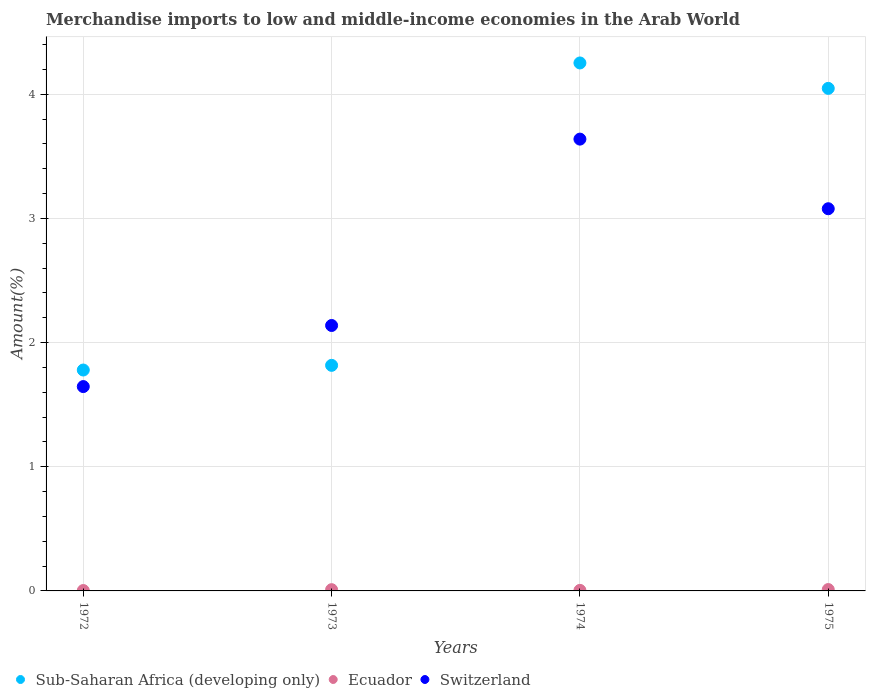What is the percentage of amount earned from merchandise imports in Sub-Saharan Africa (developing only) in 1972?
Your answer should be compact. 1.78. Across all years, what is the maximum percentage of amount earned from merchandise imports in Switzerland?
Provide a short and direct response. 3.64. Across all years, what is the minimum percentage of amount earned from merchandise imports in Sub-Saharan Africa (developing only)?
Make the answer very short. 1.78. In which year was the percentage of amount earned from merchandise imports in Sub-Saharan Africa (developing only) maximum?
Make the answer very short. 1974. In which year was the percentage of amount earned from merchandise imports in Switzerland minimum?
Your response must be concise. 1972. What is the total percentage of amount earned from merchandise imports in Sub-Saharan Africa (developing only) in the graph?
Your answer should be very brief. 11.9. What is the difference between the percentage of amount earned from merchandise imports in Switzerland in 1974 and that in 1975?
Your answer should be compact. 0.56. What is the difference between the percentage of amount earned from merchandise imports in Switzerland in 1975 and the percentage of amount earned from merchandise imports in Ecuador in 1972?
Provide a short and direct response. 3.08. What is the average percentage of amount earned from merchandise imports in Sub-Saharan Africa (developing only) per year?
Make the answer very short. 2.97. In the year 1974, what is the difference between the percentage of amount earned from merchandise imports in Switzerland and percentage of amount earned from merchandise imports in Ecuador?
Offer a terse response. 3.63. In how many years, is the percentage of amount earned from merchandise imports in Sub-Saharan Africa (developing only) greater than 3.4 %?
Your response must be concise. 2. What is the ratio of the percentage of amount earned from merchandise imports in Ecuador in 1973 to that in 1975?
Give a very brief answer. 0.91. What is the difference between the highest and the second highest percentage of amount earned from merchandise imports in Switzerland?
Ensure brevity in your answer.  0.56. What is the difference between the highest and the lowest percentage of amount earned from merchandise imports in Switzerland?
Offer a very short reply. 1.99. Does the percentage of amount earned from merchandise imports in Sub-Saharan Africa (developing only) monotonically increase over the years?
Ensure brevity in your answer.  No. Is the percentage of amount earned from merchandise imports in Switzerland strictly less than the percentage of amount earned from merchandise imports in Sub-Saharan Africa (developing only) over the years?
Make the answer very short. No. How many dotlines are there?
Make the answer very short. 3. What is the difference between two consecutive major ticks on the Y-axis?
Offer a terse response. 1. What is the title of the graph?
Give a very brief answer. Merchandise imports to low and middle-income economies in the Arab World. Does "Comoros" appear as one of the legend labels in the graph?
Your answer should be compact. No. What is the label or title of the X-axis?
Your answer should be very brief. Years. What is the label or title of the Y-axis?
Offer a terse response. Amount(%). What is the Amount(%) of Sub-Saharan Africa (developing only) in 1972?
Keep it short and to the point. 1.78. What is the Amount(%) in Ecuador in 1972?
Offer a very short reply. 0. What is the Amount(%) of Switzerland in 1972?
Keep it short and to the point. 1.65. What is the Amount(%) in Sub-Saharan Africa (developing only) in 1973?
Your response must be concise. 1.82. What is the Amount(%) in Ecuador in 1973?
Ensure brevity in your answer.  0.01. What is the Amount(%) of Switzerland in 1973?
Give a very brief answer. 2.14. What is the Amount(%) of Sub-Saharan Africa (developing only) in 1974?
Offer a very short reply. 4.25. What is the Amount(%) in Ecuador in 1974?
Make the answer very short. 0. What is the Amount(%) in Switzerland in 1974?
Your answer should be compact. 3.64. What is the Amount(%) of Sub-Saharan Africa (developing only) in 1975?
Give a very brief answer. 4.05. What is the Amount(%) of Ecuador in 1975?
Keep it short and to the point. 0.01. What is the Amount(%) in Switzerland in 1975?
Give a very brief answer. 3.08. Across all years, what is the maximum Amount(%) of Sub-Saharan Africa (developing only)?
Provide a short and direct response. 4.25. Across all years, what is the maximum Amount(%) of Ecuador?
Your answer should be compact. 0.01. Across all years, what is the maximum Amount(%) in Switzerland?
Offer a terse response. 3.64. Across all years, what is the minimum Amount(%) in Sub-Saharan Africa (developing only)?
Offer a very short reply. 1.78. Across all years, what is the minimum Amount(%) of Ecuador?
Your response must be concise. 0. Across all years, what is the minimum Amount(%) in Switzerland?
Ensure brevity in your answer.  1.65. What is the total Amount(%) of Sub-Saharan Africa (developing only) in the graph?
Keep it short and to the point. 11.9. What is the total Amount(%) in Ecuador in the graph?
Provide a succinct answer. 0.03. What is the total Amount(%) of Switzerland in the graph?
Keep it short and to the point. 10.5. What is the difference between the Amount(%) of Sub-Saharan Africa (developing only) in 1972 and that in 1973?
Provide a short and direct response. -0.04. What is the difference between the Amount(%) in Ecuador in 1972 and that in 1973?
Provide a succinct answer. -0.01. What is the difference between the Amount(%) of Switzerland in 1972 and that in 1973?
Give a very brief answer. -0.49. What is the difference between the Amount(%) of Sub-Saharan Africa (developing only) in 1972 and that in 1974?
Provide a short and direct response. -2.47. What is the difference between the Amount(%) of Ecuador in 1972 and that in 1974?
Give a very brief answer. -0. What is the difference between the Amount(%) in Switzerland in 1972 and that in 1974?
Ensure brevity in your answer.  -1.99. What is the difference between the Amount(%) of Sub-Saharan Africa (developing only) in 1972 and that in 1975?
Your response must be concise. -2.27. What is the difference between the Amount(%) in Ecuador in 1972 and that in 1975?
Offer a terse response. -0.01. What is the difference between the Amount(%) in Switzerland in 1972 and that in 1975?
Your response must be concise. -1.43. What is the difference between the Amount(%) in Sub-Saharan Africa (developing only) in 1973 and that in 1974?
Your response must be concise. -2.44. What is the difference between the Amount(%) in Ecuador in 1973 and that in 1974?
Your answer should be compact. 0.01. What is the difference between the Amount(%) of Switzerland in 1973 and that in 1974?
Keep it short and to the point. -1.5. What is the difference between the Amount(%) in Sub-Saharan Africa (developing only) in 1973 and that in 1975?
Give a very brief answer. -2.23. What is the difference between the Amount(%) of Ecuador in 1973 and that in 1975?
Provide a short and direct response. -0. What is the difference between the Amount(%) of Switzerland in 1973 and that in 1975?
Give a very brief answer. -0.94. What is the difference between the Amount(%) of Sub-Saharan Africa (developing only) in 1974 and that in 1975?
Your answer should be very brief. 0.2. What is the difference between the Amount(%) of Ecuador in 1974 and that in 1975?
Your response must be concise. -0.01. What is the difference between the Amount(%) in Switzerland in 1974 and that in 1975?
Make the answer very short. 0.56. What is the difference between the Amount(%) in Sub-Saharan Africa (developing only) in 1972 and the Amount(%) in Ecuador in 1973?
Your answer should be compact. 1.77. What is the difference between the Amount(%) of Sub-Saharan Africa (developing only) in 1972 and the Amount(%) of Switzerland in 1973?
Your response must be concise. -0.36. What is the difference between the Amount(%) in Ecuador in 1972 and the Amount(%) in Switzerland in 1973?
Your response must be concise. -2.13. What is the difference between the Amount(%) of Sub-Saharan Africa (developing only) in 1972 and the Amount(%) of Ecuador in 1974?
Your answer should be very brief. 1.77. What is the difference between the Amount(%) of Sub-Saharan Africa (developing only) in 1972 and the Amount(%) of Switzerland in 1974?
Your response must be concise. -1.86. What is the difference between the Amount(%) of Ecuador in 1972 and the Amount(%) of Switzerland in 1974?
Your response must be concise. -3.64. What is the difference between the Amount(%) of Sub-Saharan Africa (developing only) in 1972 and the Amount(%) of Ecuador in 1975?
Provide a succinct answer. 1.77. What is the difference between the Amount(%) in Sub-Saharan Africa (developing only) in 1972 and the Amount(%) in Switzerland in 1975?
Offer a terse response. -1.3. What is the difference between the Amount(%) of Ecuador in 1972 and the Amount(%) of Switzerland in 1975?
Your response must be concise. -3.08. What is the difference between the Amount(%) of Sub-Saharan Africa (developing only) in 1973 and the Amount(%) of Ecuador in 1974?
Keep it short and to the point. 1.81. What is the difference between the Amount(%) of Sub-Saharan Africa (developing only) in 1973 and the Amount(%) of Switzerland in 1974?
Offer a very short reply. -1.82. What is the difference between the Amount(%) of Ecuador in 1973 and the Amount(%) of Switzerland in 1974?
Provide a short and direct response. -3.63. What is the difference between the Amount(%) of Sub-Saharan Africa (developing only) in 1973 and the Amount(%) of Ecuador in 1975?
Provide a succinct answer. 1.81. What is the difference between the Amount(%) of Sub-Saharan Africa (developing only) in 1973 and the Amount(%) of Switzerland in 1975?
Your answer should be very brief. -1.26. What is the difference between the Amount(%) in Ecuador in 1973 and the Amount(%) in Switzerland in 1975?
Keep it short and to the point. -3.07. What is the difference between the Amount(%) of Sub-Saharan Africa (developing only) in 1974 and the Amount(%) of Ecuador in 1975?
Make the answer very short. 4.24. What is the difference between the Amount(%) of Sub-Saharan Africa (developing only) in 1974 and the Amount(%) of Switzerland in 1975?
Give a very brief answer. 1.17. What is the difference between the Amount(%) in Ecuador in 1974 and the Amount(%) in Switzerland in 1975?
Provide a short and direct response. -3.07. What is the average Amount(%) of Sub-Saharan Africa (developing only) per year?
Offer a terse response. 2.97. What is the average Amount(%) in Ecuador per year?
Give a very brief answer. 0.01. What is the average Amount(%) of Switzerland per year?
Offer a very short reply. 2.63. In the year 1972, what is the difference between the Amount(%) of Sub-Saharan Africa (developing only) and Amount(%) of Ecuador?
Offer a very short reply. 1.78. In the year 1972, what is the difference between the Amount(%) in Sub-Saharan Africa (developing only) and Amount(%) in Switzerland?
Offer a terse response. 0.13. In the year 1972, what is the difference between the Amount(%) of Ecuador and Amount(%) of Switzerland?
Your answer should be compact. -1.64. In the year 1973, what is the difference between the Amount(%) in Sub-Saharan Africa (developing only) and Amount(%) in Ecuador?
Ensure brevity in your answer.  1.81. In the year 1973, what is the difference between the Amount(%) in Sub-Saharan Africa (developing only) and Amount(%) in Switzerland?
Provide a succinct answer. -0.32. In the year 1973, what is the difference between the Amount(%) of Ecuador and Amount(%) of Switzerland?
Keep it short and to the point. -2.13. In the year 1974, what is the difference between the Amount(%) of Sub-Saharan Africa (developing only) and Amount(%) of Ecuador?
Keep it short and to the point. 4.25. In the year 1974, what is the difference between the Amount(%) in Sub-Saharan Africa (developing only) and Amount(%) in Switzerland?
Offer a terse response. 0.61. In the year 1974, what is the difference between the Amount(%) of Ecuador and Amount(%) of Switzerland?
Offer a terse response. -3.63. In the year 1975, what is the difference between the Amount(%) in Sub-Saharan Africa (developing only) and Amount(%) in Ecuador?
Offer a terse response. 4.04. In the year 1975, what is the difference between the Amount(%) of Sub-Saharan Africa (developing only) and Amount(%) of Switzerland?
Keep it short and to the point. 0.97. In the year 1975, what is the difference between the Amount(%) in Ecuador and Amount(%) in Switzerland?
Offer a terse response. -3.07. What is the ratio of the Amount(%) of Sub-Saharan Africa (developing only) in 1972 to that in 1973?
Make the answer very short. 0.98. What is the ratio of the Amount(%) in Ecuador in 1972 to that in 1973?
Ensure brevity in your answer.  0.31. What is the ratio of the Amount(%) in Switzerland in 1972 to that in 1973?
Your answer should be compact. 0.77. What is the ratio of the Amount(%) in Sub-Saharan Africa (developing only) in 1972 to that in 1974?
Ensure brevity in your answer.  0.42. What is the ratio of the Amount(%) in Ecuador in 1972 to that in 1974?
Offer a very short reply. 0.71. What is the ratio of the Amount(%) of Switzerland in 1972 to that in 1974?
Make the answer very short. 0.45. What is the ratio of the Amount(%) of Sub-Saharan Africa (developing only) in 1972 to that in 1975?
Your answer should be very brief. 0.44. What is the ratio of the Amount(%) of Ecuador in 1972 to that in 1975?
Provide a succinct answer. 0.28. What is the ratio of the Amount(%) in Switzerland in 1972 to that in 1975?
Make the answer very short. 0.53. What is the ratio of the Amount(%) in Sub-Saharan Africa (developing only) in 1973 to that in 1974?
Make the answer very short. 0.43. What is the ratio of the Amount(%) of Ecuador in 1973 to that in 1974?
Ensure brevity in your answer.  2.28. What is the ratio of the Amount(%) in Switzerland in 1973 to that in 1974?
Your answer should be very brief. 0.59. What is the ratio of the Amount(%) in Sub-Saharan Africa (developing only) in 1973 to that in 1975?
Ensure brevity in your answer.  0.45. What is the ratio of the Amount(%) in Ecuador in 1973 to that in 1975?
Ensure brevity in your answer.  0.91. What is the ratio of the Amount(%) of Switzerland in 1973 to that in 1975?
Provide a short and direct response. 0.69. What is the ratio of the Amount(%) of Sub-Saharan Africa (developing only) in 1974 to that in 1975?
Ensure brevity in your answer.  1.05. What is the ratio of the Amount(%) in Ecuador in 1974 to that in 1975?
Keep it short and to the point. 0.4. What is the ratio of the Amount(%) of Switzerland in 1974 to that in 1975?
Your answer should be very brief. 1.18. What is the difference between the highest and the second highest Amount(%) of Sub-Saharan Africa (developing only)?
Give a very brief answer. 0.2. What is the difference between the highest and the second highest Amount(%) in Switzerland?
Ensure brevity in your answer.  0.56. What is the difference between the highest and the lowest Amount(%) in Sub-Saharan Africa (developing only)?
Provide a succinct answer. 2.47. What is the difference between the highest and the lowest Amount(%) of Ecuador?
Offer a very short reply. 0.01. What is the difference between the highest and the lowest Amount(%) of Switzerland?
Offer a very short reply. 1.99. 